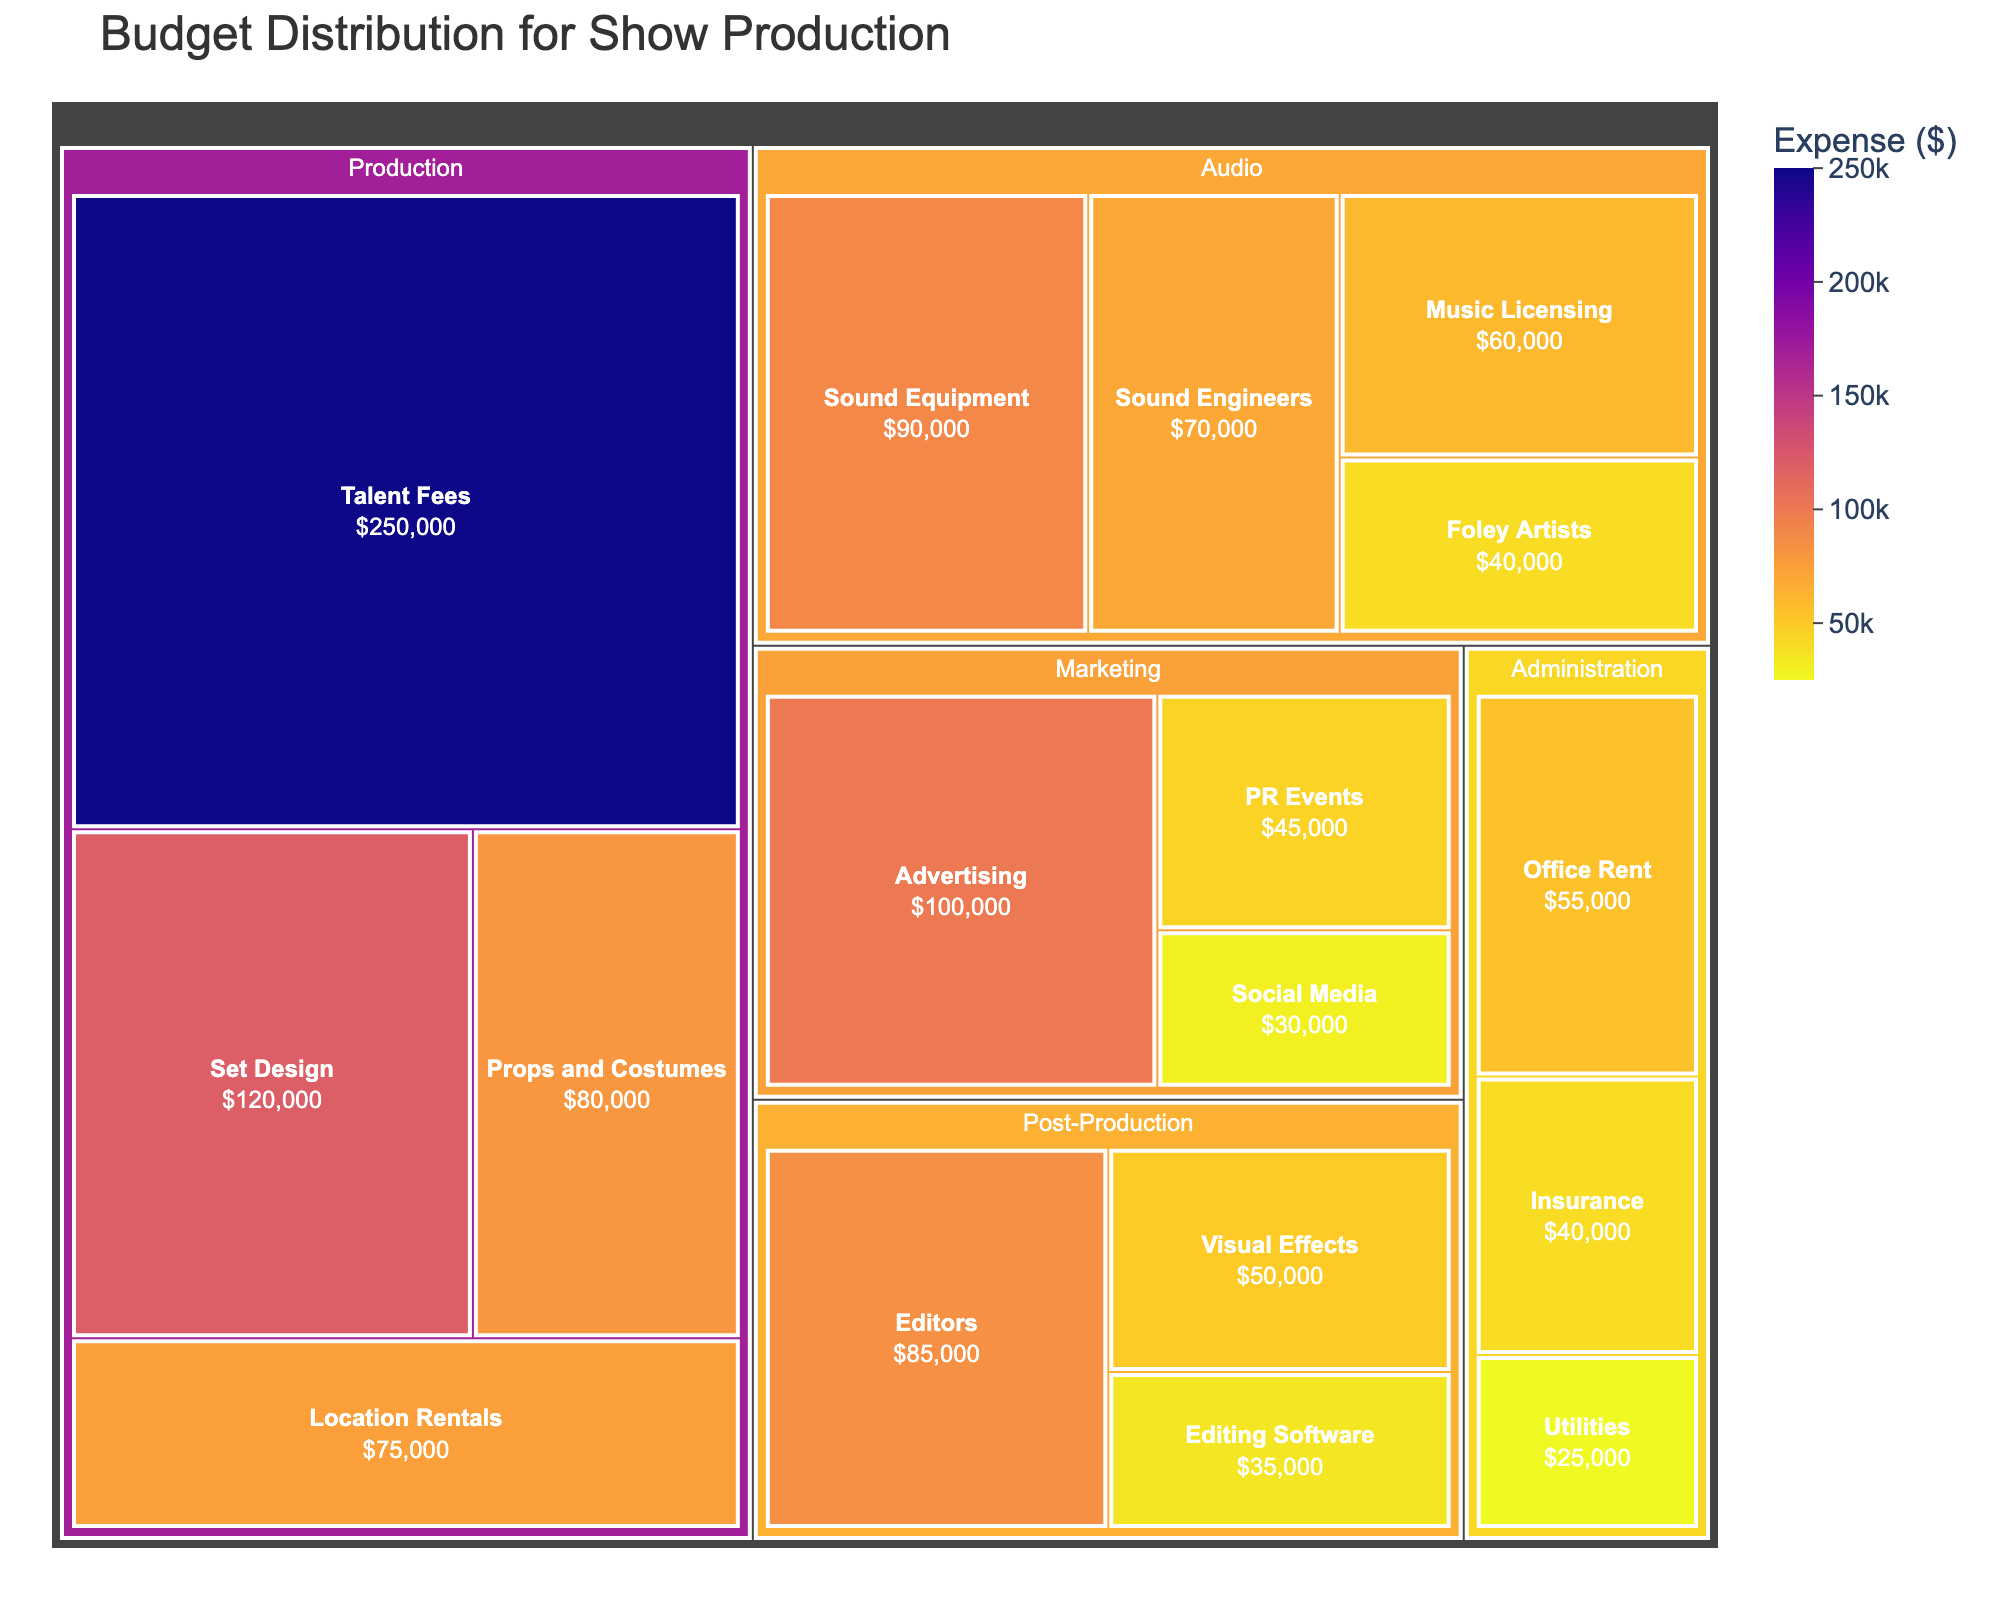What's the title of the treemap? The title is usually displayed at the top of the plot. In this case, the title should be clear and descriptive, mentioning the purpose of the plot.
Answer: Budget Distribution for Show Production Which department has the highest total expense? Look at the largest segment in the treemap, which represents the department with the highest total expense. The size of the segment indicates the total expense.
Answer: Production What is the total expense for the Audio department? Identify the segment for the Audio department in the treemap and sum up all the individual categories within that segment.
Answer: $260,000 What is the difference in expense between Talent Fees and Advertising? Observe the individual categories for Talent Fees and Advertising. Subtract the lesser value from the greater value to get the difference. Talent Fees are $250,000 and Advertising is $100,000.
Answer: $150,000 Which category in the Post-Production department incurs the most expense? Look at the categories within the Post-Production department segment and identify the one with the largest size (the most expense).
Answer: Editors How does the expense for Set Design compare to that for Sound Engineers? Find the segments for Set Design and Sound Engineers, then compare their expenses. Set Design is $120,000 and Sound Engineers is $70,000.
Answer: Set Design has a higher expense What is the smallest expense listed in the treemap? Identify the smallest segment in the treemap, which represents the category with the smallest expense.
Answer: Utilities ($25,000) Which department has the lowest total expense? Find the smallest overall segment representing a department by summing up all categories for each department and identifying the smallest total.
Answer: Administration Between the categories in the Marketing department, which one has the highest expense? Within the Marketing department segment, identify the largest individual category by expense size.
Answer: Advertising Compare the total expenses of Production and Marketing departments. Which one is higher and by how much? Sum up all expenses within Production and Marketing departments separately and compare. Production is $525,000, Marketing is $175,000. Subtract the smaller total from the larger one.
Answer: Production is higher by $350,000 